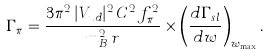Convert formula to latex. <formula><loc_0><loc_0><loc_500><loc_500>\Gamma _ { \pi } = { \frac { 3 \pi ^ { 2 } \, | V _ { u d } | ^ { 2 } \, C ^ { 2 } \, f _ { \pi } ^ { 2 } } { m _ { B } ^ { 2 } \, r } } \times \left ( { \frac { d \Gamma _ { s l } } { d w } } \right ) _ { w _ { \max } } .</formula> 